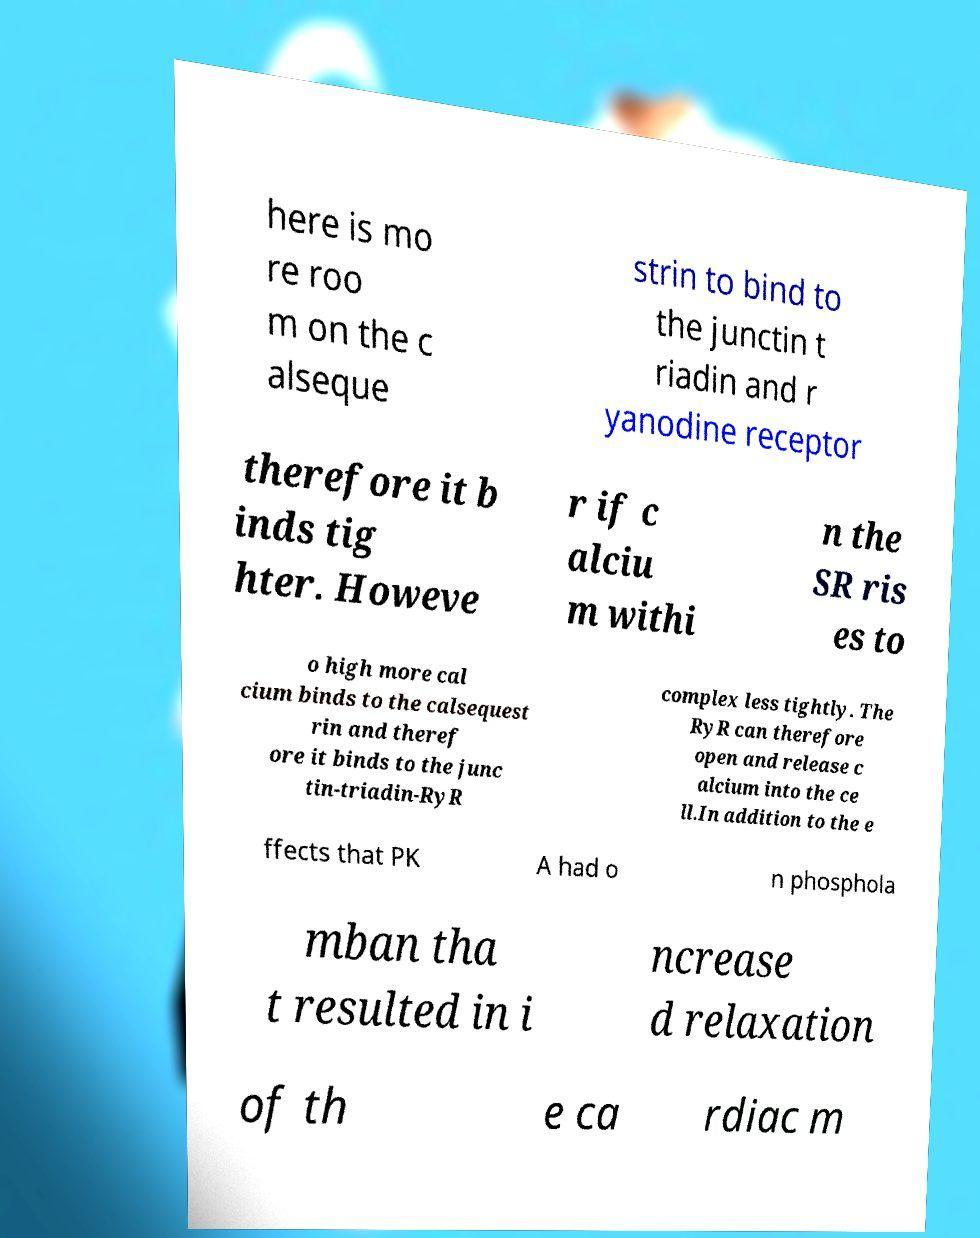There's text embedded in this image that I need extracted. Can you transcribe it verbatim? here is mo re roo m on the c alseque strin to bind to the junctin t riadin and r yanodine receptor therefore it b inds tig hter. Howeve r if c alciu m withi n the SR ris es to o high more cal cium binds to the calsequest rin and theref ore it binds to the junc tin-triadin-RyR complex less tightly. The RyR can therefore open and release c alcium into the ce ll.In addition to the e ffects that PK A had o n phosphola mban tha t resulted in i ncrease d relaxation of th e ca rdiac m 